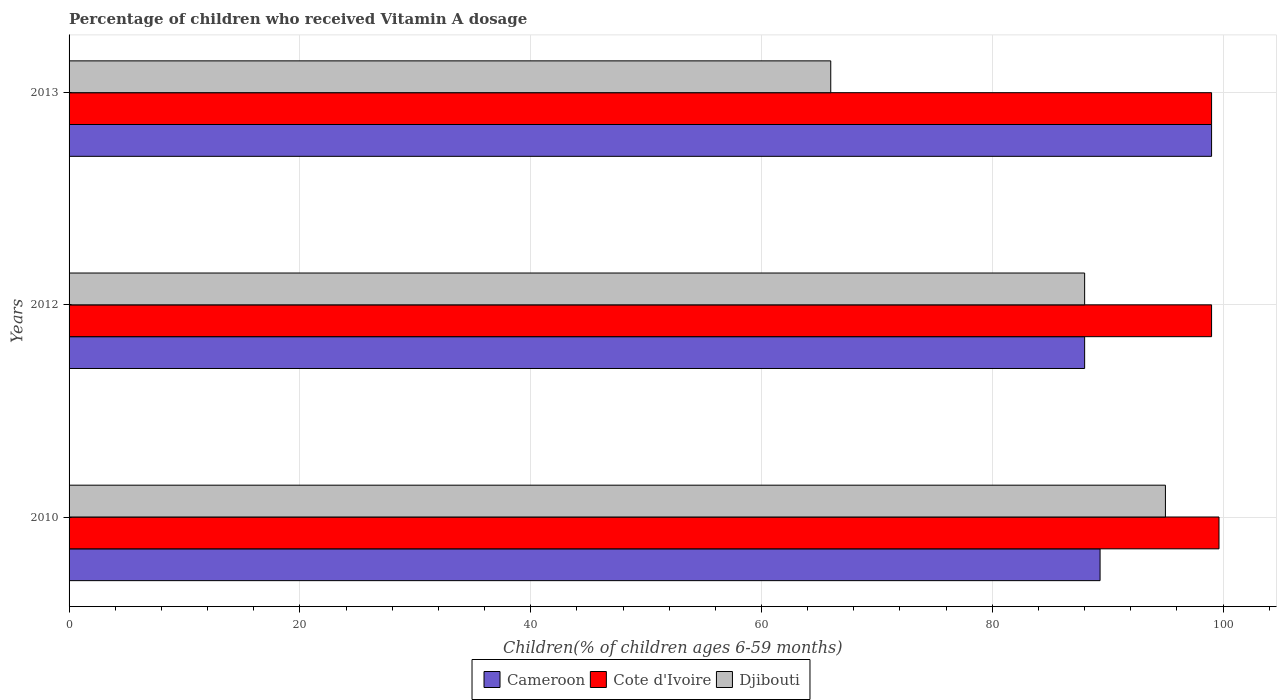How many different coloured bars are there?
Keep it short and to the point. 3. How many groups of bars are there?
Your answer should be compact. 3. Are the number of bars per tick equal to the number of legend labels?
Keep it short and to the point. Yes. Are the number of bars on each tick of the Y-axis equal?
Your answer should be very brief. Yes. What is the label of the 3rd group of bars from the top?
Provide a short and direct response. 2010. What is the percentage of children who received Vitamin A dosage in Cote d'Ivoire in 2012?
Provide a succinct answer. 99. In which year was the percentage of children who received Vitamin A dosage in Cameroon maximum?
Make the answer very short. 2013. In which year was the percentage of children who received Vitamin A dosage in Djibouti minimum?
Your response must be concise. 2013. What is the total percentage of children who received Vitamin A dosage in Cameroon in the graph?
Your answer should be very brief. 276.34. What is the difference between the percentage of children who received Vitamin A dosage in Djibouti in 2012 and that in 2013?
Provide a succinct answer. 22. What is the difference between the percentage of children who received Vitamin A dosage in Djibouti in 2010 and the percentage of children who received Vitamin A dosage in Cote d'Ivoire in 2012?
Offer a terse response. -4. What is the average percentage of children who received Vitamin A dosage in Djibouti per year?
Provide a succinct answer. 83. In the year 2010, what is the difference between the percentage of children who received Vitamin A dosage in Cote d'Ivoire and percentage of children who received Vitamin A dosage in Djibouti?
Provide a short and direct response. 4.64. In how many years, is the percentage of children who received Vitamin A dosage in Cameroon greater than 76 %?
Ensure brevity in your answer.  3. What is the ratio of the percentage of children who received Vitamin A dosage in Cote d'Ivoire in 2012 to that in 2013?
Your answer should be compact. 1. Is the difference between the percentage of children who received Vitamin A dosage in Cote d'Ivoire in 2012 and 2013 greater than the difference between the percentage of children who received Vitamin A dosage in Djibouti in 2012 and 2013?
Your answer should be very brief. No. What is the difference between the highest and the second highest percentage of children who received Vitamin A dosage in Djibouti?
Ensure brevity in your answer.  7. In how many years, is the percentage of children who received Vitamin A dosage in Cameroon greater than the average percentage of children who received Vitamin A dosage in Cameroon taken over all years?
Give a very brief answer. 1. Is the sum of the percentage of children who received Vitamin A dosage in Cameroon in 2010 and 2012 greater than the maximum percentage of children who received Vitamin A dosage in Cote d'Ivoire across all years?
Provide a short and direct response. Yes. What does the 2nd bar from the top in 2013 represents?
Make the answer very short. Cote d'Ivoire. What does the 2nd bar from the bottom in 2010 represents?
Provide a succinct answer. Cote d'Ivoire. Is it the case that in every year, the sum of the percentage of children who received Vitamin A dosage in Cameroon and percentage of children who received Vitamin A dosage in Djibouti is greater than the percentage of children who received Vitamin A dosage in Cote d'Ivoire?
Provide a short and direct response. Yes. How many years are there in the graph?
Offer a terse response. 3. What is the difference between two consecutive major ticks on the X-axis?
Provide a succinct answer. 20. Are the values on the major ticks of X-axis written in scientific E-notation?
Offer a very short reply. No. Does the graph contain any zero values?
Give a very brief answer. No. Does the graph contain grids?
Offer a very short reply. Yes. Where does the legend appear in the graph?
Your response must be concise. Bottom center. What is the title of the graph?
Provide a succinct answer. Percentage of children who received Vitamin A dosage. Does "Samoa" appear as one of the legend labels in the graph?
Make the answer very short. No. What is the label or title of the X-axis?
Your response must be concise. Children(% of children ages 6-59 months). What is the label or title of the Y-axis?
Make the answer very short. Years. What is the Children(% of children ages 6-59 months) in Cameroon in 2010?
Your answer should be compact. 89.34. What is the Children(% of children ages 6-59 months) of Cote d'Ivoire in 2010?
Keep it short and to the point. 99.64. What is the Children(% of children ages 6-59 months) of Djibouti in 2010?
Your answer should be very brief. 95. What is the Children(% of children ages 6-59 months) of Cameroon in 2013?
Give a very brief answer. 99. What is the Children(% of children ages 6-59 months) in Cote d'Ivoire in 2013?
Make the answer very short. 99. What is the Children(% of children ages 6-59 months) of Djibouti in 2013?
Your answer should be very brief. 66. Across all years, what is the maximum Children(% of children ages 6-59 months) in Cote d'Ivoire?
Your answer should be compact. 99.64. Across all years, what is the maximum Children(% of children ages 6-59 months) in Djibouti?
Give a very brief answer. 95. Across all years, what is the minimum Children(% of children ages 6-59 months) in Cameroon?
Ensure brevity in your answer.  88. What is the total Children(% of children ages 6-59 months) in Cameroon in the graph?
Make the answer very short. 276.34. What is the total Children(% of children ages 6-59 months) in Cote d'Ivoire in the graph?
Your response must be concise. 297.64. What is the total Children(% of children ages 6-59 months) in Djibouti in the graph?
Make the answer very short. 249. What is the difference between the Children(% of children ages 6-59 months) in Cameroon in 2010 and that in 2012?
Your response must be concise. 1.34. What is the difference between the Children(% of children ages 6-59 months) of Cote d'Ivoire in 2010 and that in 2012?
Provide a short and direct response. 0.64. What is the difference between the Children(% of children ages 6-59 months) of Djibouti in 2010 and that in 2012?
Your response must be concise. 7. What is the difference between the Children(% of children ages 6-59 months) of Cameroon in 2010 and that in 2013?
Your response must be concise. -9.66. What is the difference between the Children(% of children ages 6-59 months) in Cote d'Ivoire in 2010 and that in 2013?
Offer a very short reply. 0.64. What is the difference between the Children(% of children ages 6-59 months) of Djibouti in 2010 and that in 2013?
Offer a very short reply. 29. What is the difference between the Children(% of children ages 6-59 months) in Djibouti in 2012 and that in 2013?
Offer a terse response. 22. What is the difference between the Children(% of children ages 6-59 months) of Cameroon in 2010 and the Children(% of children ages 6-59 months) of Cote d'Ivoire in 2012?
Your answer should be very brief. -9.66. What is the difference between the Children(% of children ages 6-59 months) of Cameroon in 2010 and the Children(% of children ages 6-59 months) of Djibouti in 2012?
Your answer should be compact. 1.34. What is the difference between the Children(% of children ages 6-59 months) of Cote d'Ivoire in 2010 and the Children(% of children ages 6-59 months) of Djibouti in 2012?
Offer a very short reply. 11.64. What is the difference between the Children(% of children ages 6-59 months) of Cameroon in 2010 and the Children(% of children ages 6-59 months) of Cote d'Ivoire in 2013?
Offer a terse response. -9.66. What is the difference between the Children(% of children ages 6-59 months) in Cameroon in 2010 and the Children(% of children ages 6-59 months) in Djibouti in 2013?
Provide a short and direct response. 23.34. What is the difference between the Children(% of children ages 6-59 months) in Cote d'Ivoire in 2010 and the Children(% of children ages 6-59 months) in Djibouti in 2013?
Your answer should be very brief. 33.64. What is the difference between the Children(% of children ages 6-59 months) of Cameroon in 2012 and the Children(% of children ages 6-59 months) of Djibouti in 2013?
Make the answer very short. 22. What is the difference between the Children(% of children ages 6-59 months) in Cote d'Ivoire in 2012 and the Children(% of children ages 6-59 months) in Djibouti in 2013?
Keep it short and to the point. 33. What is the average Children(% of children ages 6-59 months) in Cameroon per year?
Your answer should be very brief. 92.11. What is the average Children(% of children ages 6-59 months) of Cote d'Ivoire per year?
Make the answer very short. 99.21. What is the average Children(% of children ages 6-59 months) in Djibouti per year?
Your answer should be very brief. 83. In the year 2010, what is the difference between the Children(% of children ages 6-59 months) of Cameroon and Children(% of children ages 6-59 months) of Cote d'Ivoire?
Your answer should be very brief. -10.3. In the year 2010, what is the difference between the Children(% of children ages 6-59 months) of Cameroon and Children(% of children ages 6-59 months) of Djibouti?
Ensure brevity in your answer.  -5.66. In the year 2010, what is the difference between the Children(% of children ages 6-59 months) in Cote d'Ivoire and Children(% of children ages 6-59 months) in Djibouti?
Offer a very short reply. 4.64. In the year 2012, what is the difference between the Children(% of children ages 6-59 months) of Cameroon and Children(% of children ages 6-59 months) of Cote d'Ivoire?
Provide a succinct answer. -11. In the year 2012, what is the difference between the Children(% of children ages 6-59 months) in Cameroon and Children(% of children ages 6-59 months) in Djibouti?
Provide a succinct answer. 0. In the year 2012, what is the difference between the Children(% of children ages 6-59 months) in Cote d'Ivoire and Children(% of children ages 6-59 months) in Djibouti?
Provide a short and direct response. 11. What is the ratio of the Children(% of children ages 6-59 months) of Cameroon in 2010 to that in 2012?
Ensure brevity in your answer.  1.02. What is the ratio of the Children(% of children ages 6-59 months) of Djibouti in 2010 to that in 2012?
Your answer should be compact. 1.08. What is the ratio of the Children(% of children ages 6-59 months) in Cameroon in 2010 to that in 2013?
Offer a very short reply. 0.9. What is the ratio of the Children(% of children ages 6-59 months) in Djibouti in 2010 to that in 2013?
Give a very brief answer. 1.44. What is the ratio of the Children(% of children ages 6-59 months) of Cameroon in 2012 to that in 2013?
Provide a short and direct response. 0.89. What is the ratio of the Children(% of children ages 6-59 months) of Cote d'Ivoire in 2012 to that in 2013?
Your answer should be compact. 1. What is the ratio of the Children(% of children ages 6-59 months) of Djibouti in 2012 to that in 2013?
Keep it short and to the point. 1.33. What is the difference between the highest and the second highest Children(% of children ages 6-59 months) in Cameroon?
Provide a succinct answer. 9.66. What is the difference between the highest and the second highest Children(% of children ages 6-59 months) of Cote d'Ivoire?
Keep it short and to the point. 0.64. What is the difference between the highest and the lowest Children(% of children ages 6-59 months) of Cote d'Ivoire?
Provide a succinct answer. 0.64. 